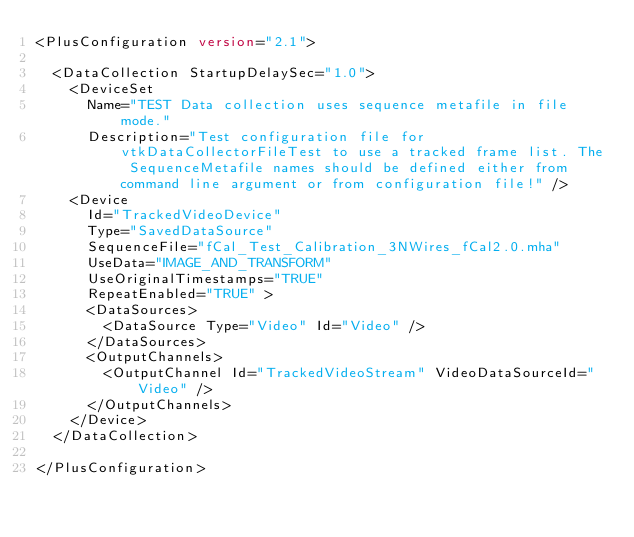<code> <loc_0><loc_0><loc_500><loc_500><_XML_><PlusConfiguration version="2.1">

  <DataCollection StartupDelaySec="1.0">
    <DeviceSet 
      Name="TEST Data collection uses sequence metafile in file mode." 
      Description="Test configuration file for vtkDataCollectorFileTest to use a tracked frame list. The SequenceMetafile names should be defined either from command line argument or from configuration file!" />      
    <Device
      Id="TrackedVideoDevice"
      Type="SavedDataSource"
      SequenceFile="fCal_Test_Calibration_3NWires_fCal2.0.mha"
      UseData="IMAGE_AND_TRANSFORM"
      UseOriginalTimestamps="TRUE"
      RepeatEnabled="TRUE" >
      <DataSources>
        <DataSource Type="Video" Id="Video" />
      </DataSources>
      <OutputChannels>
        <OutputChannel Id="TrackedVideoStream" VideoDataSourceId="Video" />
      </OutputChannels>
    </Device>
  </DataCollection>

</PlusConfiguration>
</code> 